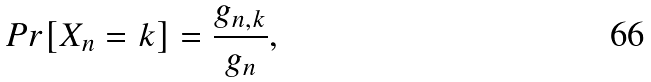<formula> <loc_0><loc_0><loc_500><loc_500>P r [ X _ { n } = k ] = \frac { g _ { n , k } } { g _ { n } } ,</formula> 